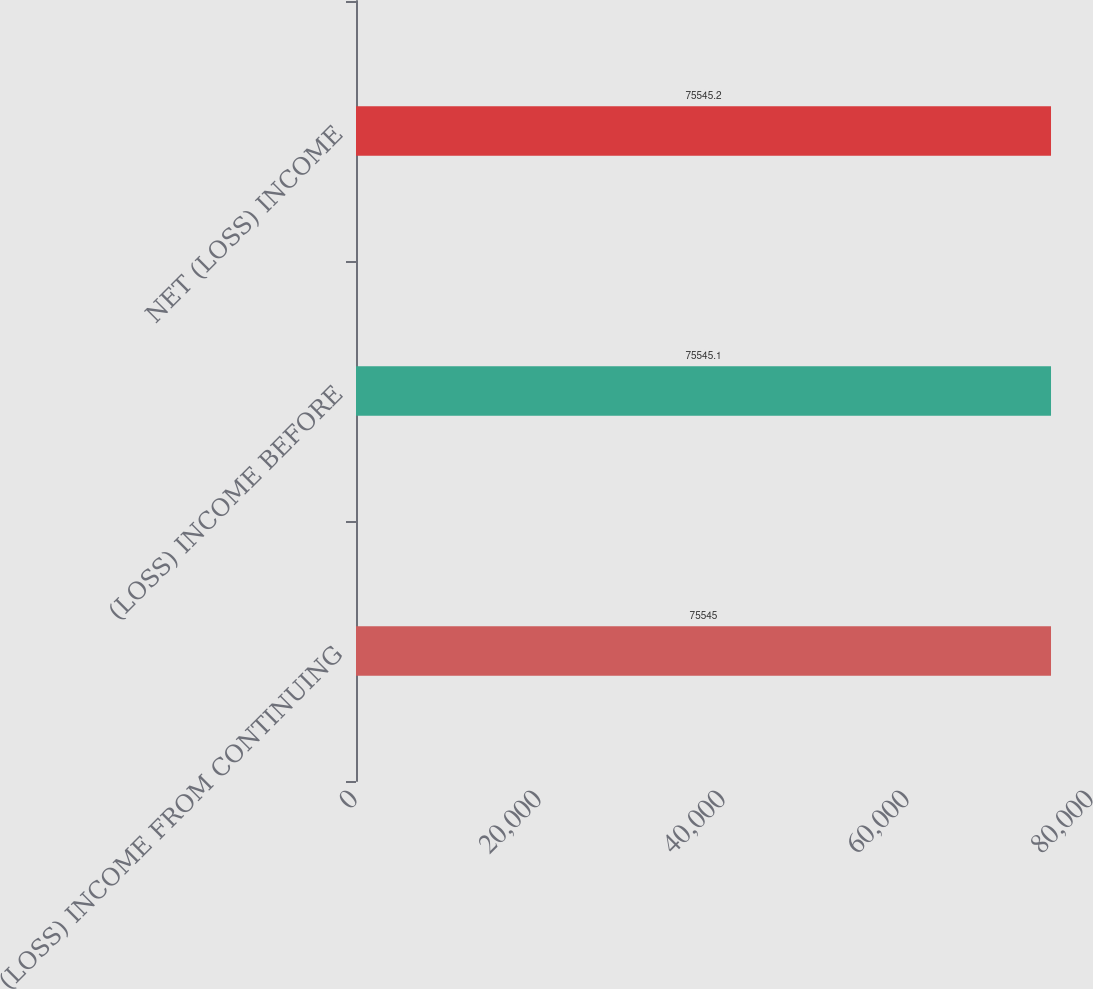Convert chart. <chart><loc_0><loc_0><loc_500><loc_500><bar_chart><fcel>(LOSS) INCOME FROM CONTINUING<fcel>(LOSS) INCOME BEFORE<fcel>NET (LOSS) INCOME<nl><fcel>75545<fcel>75545.1<fcel>75545.2<nl></chart> 